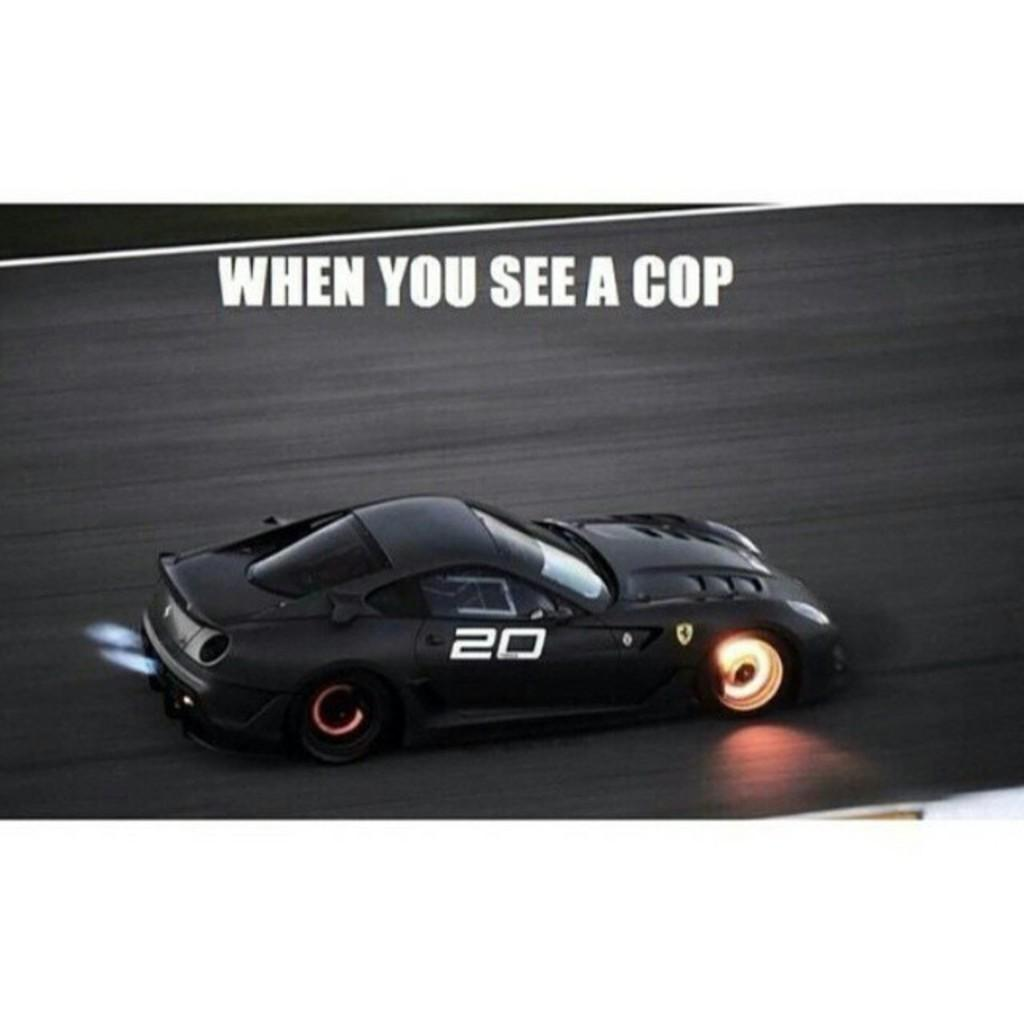What is featured on the poster in the image? The poster contains a car on the road. What else can be seen on the poster besides the car? There is text on the poster. What type of boats are racing in the image? There are no boats present in the image; it features a poster with a car on the road. What team is responsible for creating the poster in the image? There is no information about a team responsible for creating the poster in the image. 